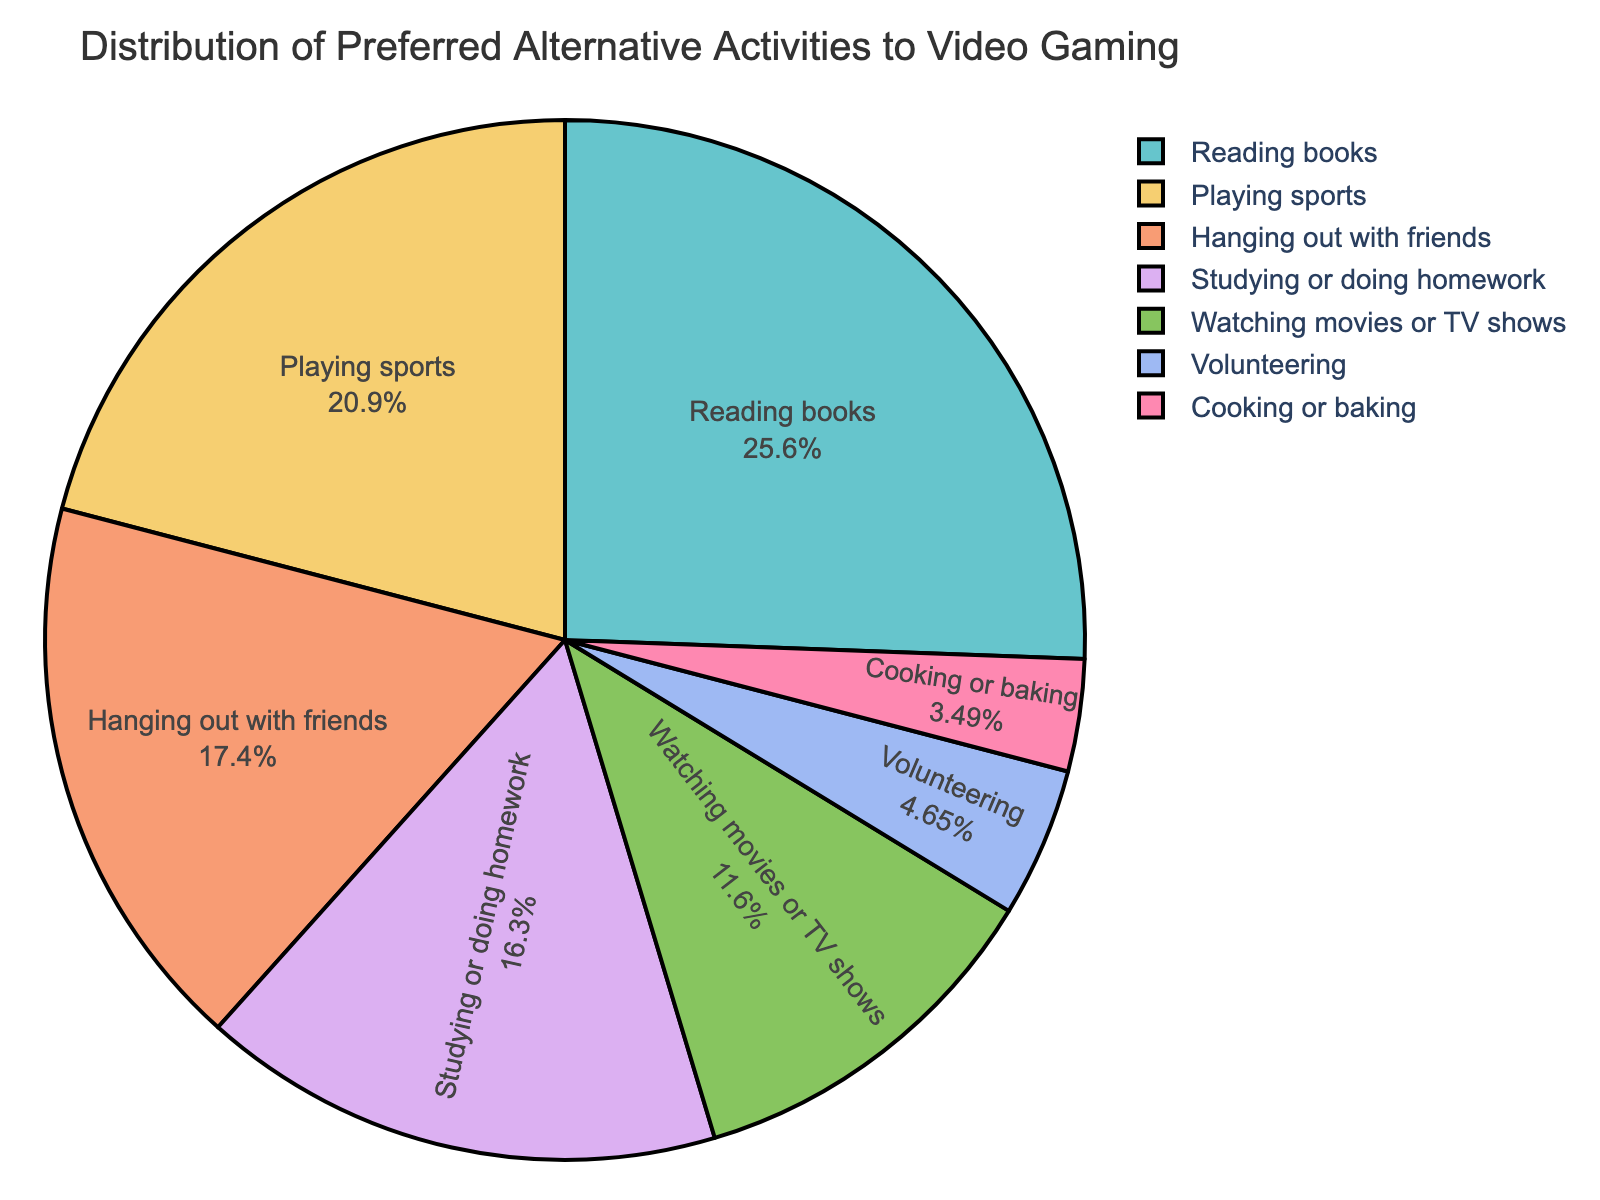What's the most popular activity to do instead of video gaming? The pie chart shows the distribution of various activities. The activity with the largest percentage slice is the most popular. In this case, Reading books has the highest percentage.
Answer: Reading books Which activities have a percentage greater than 15%? Refer to the pie chart and identify the activities where the percentage slice is greater than 15%. These are Reading books (22%) and Playing sports (18%).
Answer: Reading books, Playing sports What is the total percentage of students engaged in studying or doing homework, and watching movies or TV shows? Look at the slices for Studying or doing homework (14%) and Watching movies or TV shows (10%). Add these percentages together: 14% + 10% = 24%.
Answer: 24% How much larger is the percentage of students who read books compared to those who volunteer? Compare the slices of Reading books (22%) and Volunteering (4%). Calculate the difference: 22% - 4% = 18%.
Answer: 18% Which activity has a smaller percentage: cooking or baking, or volunteering? Observe the pie chart and compare the slices for Cooking or baking (3%) and Volunteering (4%). The Cooking or baking slice is smaller.
Answer: Cooking or baking What is the total percentage of students preferring activities not related to sports (not including Playing sports)? Sum the percentages of all activities except Playing sports: Reading books (22%), Hanging out with friends (15%), Studying or doing homework (14%), Watching movies or TV shows (10%), Volunteering (4%), Cooking or baking (3%). Calculate the sum: 22% + 15% + 14% + 10% + 4% + 3% = 68%.
Answer: 68% What percentage difference is there between students who hang out with friends and those who study or do homework? Compare the slices for Hanging out with friends (15%) and Studying or doing homework (14%). Calculate the difference: 15% - 14% = 1%.
Answer: 1% Is the combined percentage of Playing sports and Volunteering greater than 20%? Add the percentages for Playing sports (18%) and Volunteering (4%). Calculate the sum: 18% + 4% = 22%. Since 22% is greater than 20%, the answer is yes.
Answer: Yes 